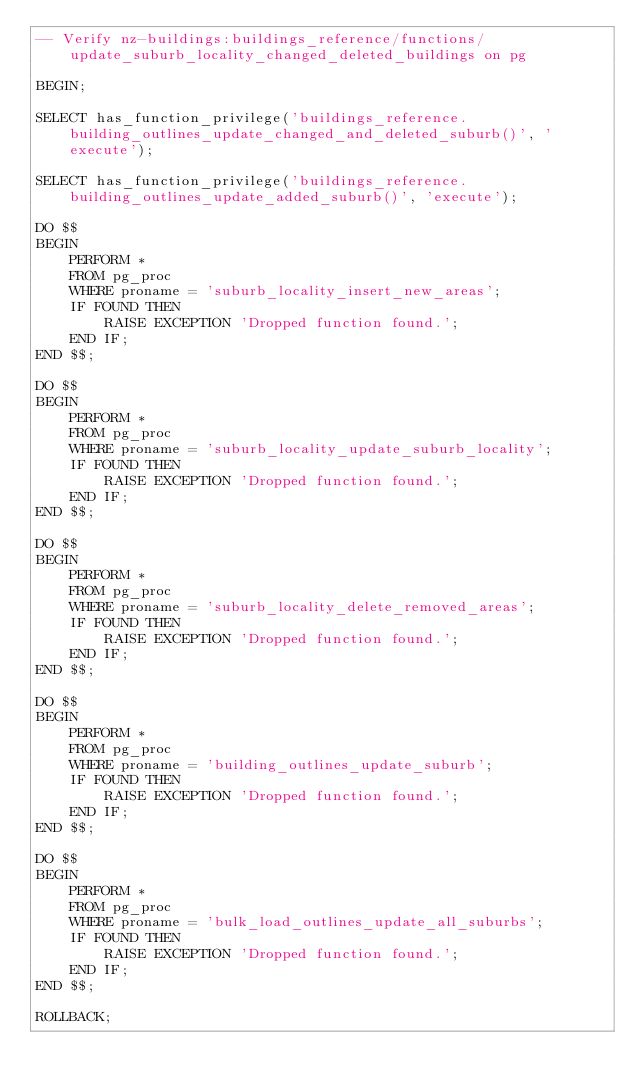Convert code to text. <code><loc_0><loc_0><loc_500><loc_500><_SQL_>-- Verify nz-buildings:buildings_reference/functions/update_suburb_locality_changed_deleted_buildings on pg

BEGIN;

SELECT has_function_privilege('buildings_reference.building_outlines_update_changed_and_deleted_suburb()', 'execute');

SELECT has_function_privilege('buildings_reference.building_outlines_update_added_suburb()', 'execute');

DO $$
BEGIN
    PERFORM *
    FROM pg_proc
    WHERE proname = 'suburb_locality_insert_new_areas';
    IF FOUND THEN
        RAISE EXCEPTION 'Dropped function found.';
    END IF;
END $$;

DO $$
BEGIN
    PERFORM *
    FROM pg_proc
    WHERE proname = 'suburb_locality_update_suburb_locality';
    IF FOUND THEN
        RAISE EXCEPTION 'Dropped function found.';
    END IF;
END $$;

DO $$
BEGIN
    PERFORM *
    FROM pg_proc
    WHERE proname = 'suburb_locality_delete_removed_areas';
    IF FOUND THEN
        RAISE EXCEPTION 'Dropped function found.';
    END IF;
END $$;

DO $$
BEGIN
    PERFORM *
    FROM pg_proc
    WHERE proname = 'building_outlines_update_suburb';
    IF FOUND THEN
        RAISE EXCEPTION 'Dropped function found.';
    END IF;
END $$;

DO $$
BEGIN
    PERFORM *
    FROM pg_proc
    WHERE proname = 'bulk_load_outlines_update_all_suburbs';
    IF FOUND THEN
        RAISE EXCEPTION 'Dropped function found.';
    END IF;
END $$;

ROLLBACK;
</code> 